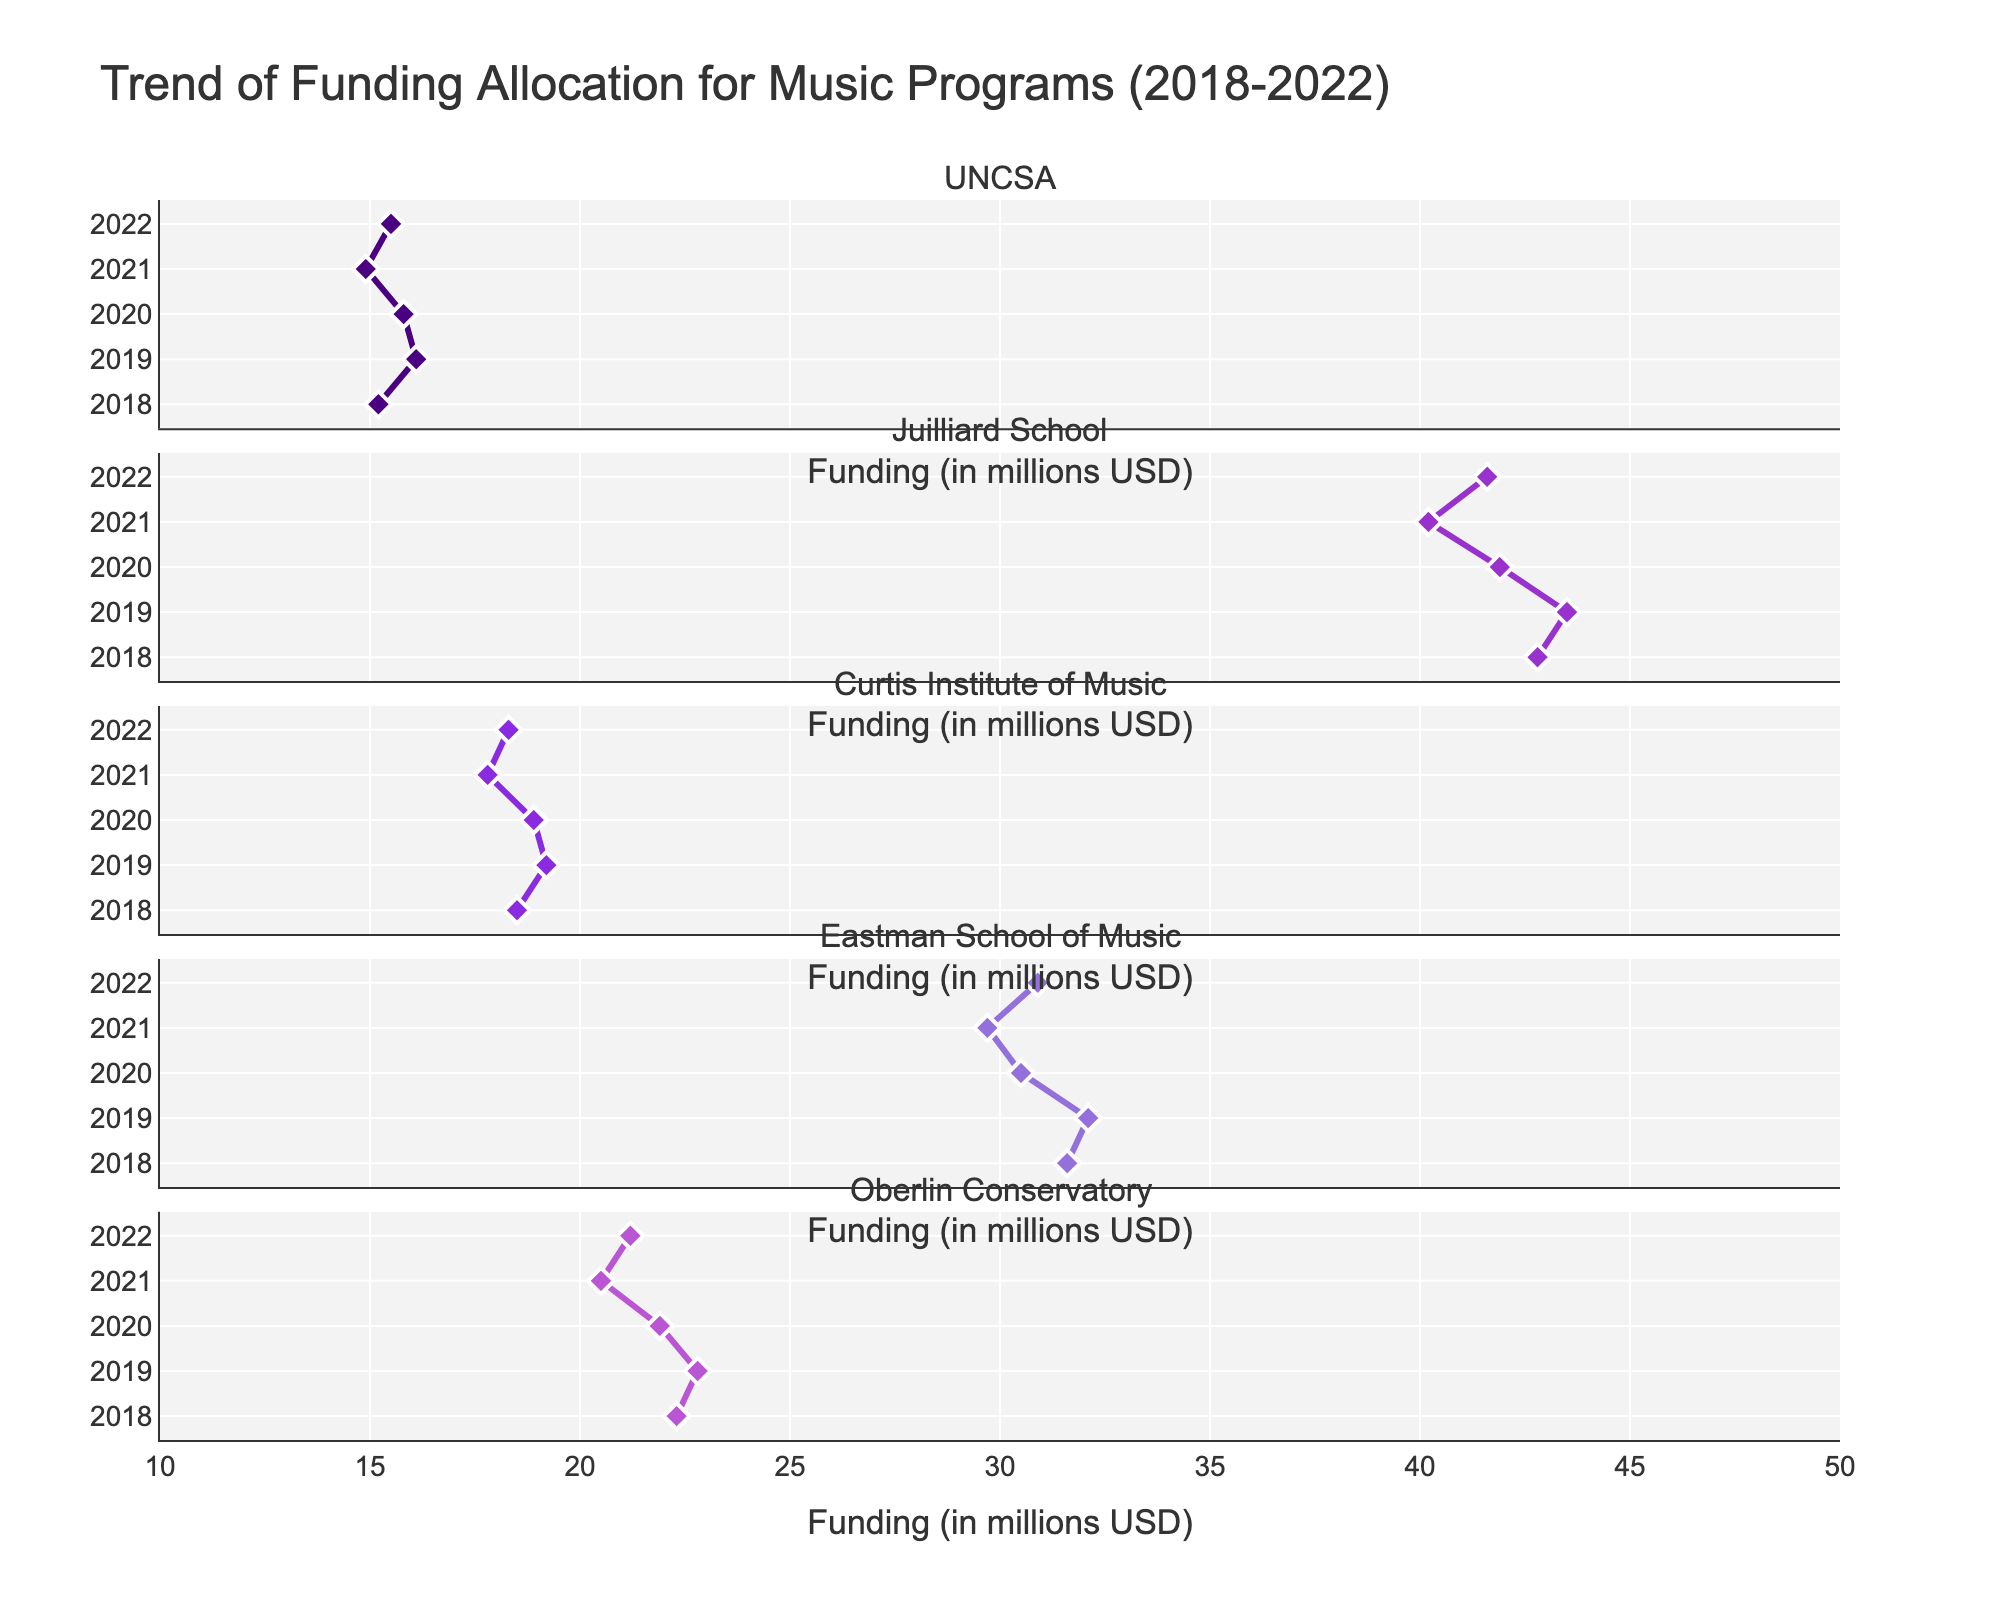What percentage of the land was used for agriculture in 1980? The agricultural subplot shows the percentage for 1980 at around 85%.
Answer: 85% How did the percentage of land used for residential purposes change between 1990 and 2020? In 1990, the residential land use was 18%, and it increased to 48% by 2020. So, the change is 48% - 18% = 30%.
Answer: 30% Which year shows the greatest agricultural land usage among all years listed? By examining the agricultural subplot, 1980 has the highest agricultural land use percentage, which is 85%.
Answer: 1980 Compare the commercial land usage between 2000 and 2030. What can you observe? The commercial land usage was 12% in 2000 and is projected to be 25% in 2030, indicating an increase of 13%.
Answer: Increased by 13% What is the general trend in agricultural land usage from 1980 to 2030? The agricultural land usage consistently decreases over the years, from 85% in 1980 to 20% in 2030.
Answer: Decreasing What is the difference in the percentage of residential land between 2010 and 2020? Residential land usage in 2010 was 38%, and in 2020 it was 48%. The difference is 48% - 38% = 10%.
Answer: 10% What type of land use had the most significant increase from 1980 to 2020? The residential land use increased from 12% in 1980 to 48% in 2020, an increase of 36%. This is more than the increases in agricultural or commercial land uses.
Answer: Residential Between which two consecutive decades did the commercial land usage experience the biggest increase? The commercial land usage experienced the biggest increase between 2000 (12%) and 2010 (17%), which is a 5% increase.
Answer: 2000-2010 In which period did agricultural land experience the sharpest decline, and by how much? The sharpest decline in agricultural land was from 2000 (60%) to 2010 (45%), a decrease of 15%.
Answer: 2000-2010, 15% 